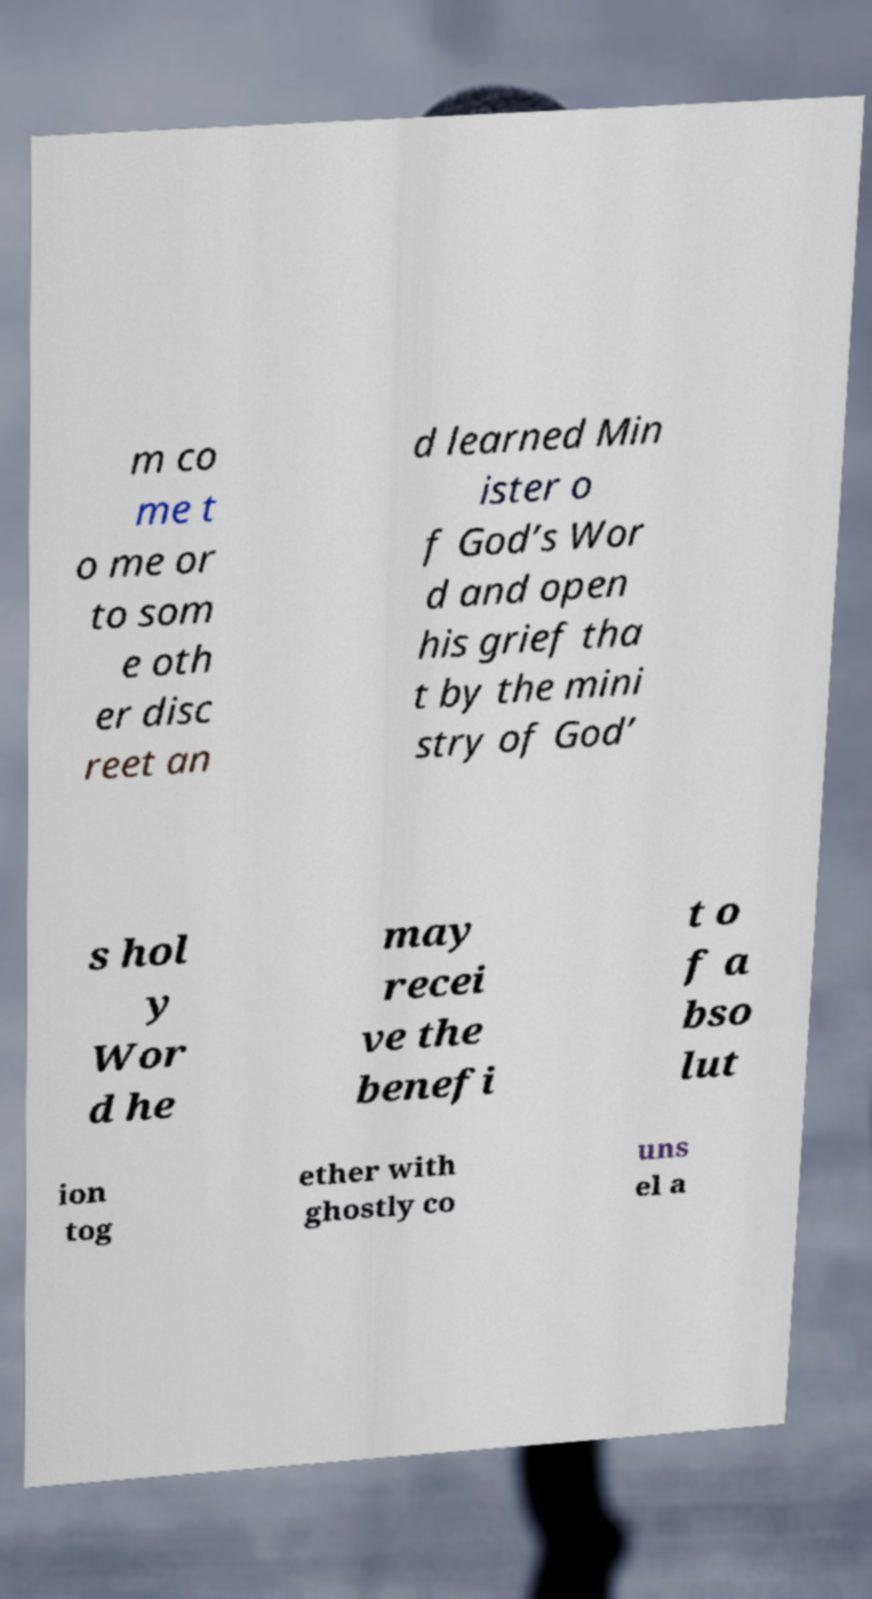Please read and relay the text visible in this image. What does it say? m co me t o me or to som e oth er disc reet an d learned Min ister o f God’s Wor d and open his grief tha t by the mini stry of God’ s hol y Wor d he may recei ve the benefi t o f a bso lut ion tog ether with ghostly co uns el a 